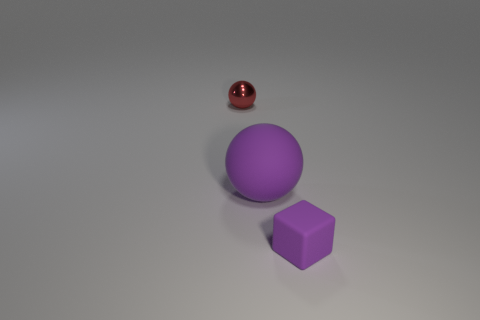What number of things are balls on the right side of the small metallic object or tiny red metallic objects?
Your answer should be compact. 2. Are there an equal number of tiny metal balls that are on the right side of the purple sphere and metal spheres in front of the small red ball?
Offer a very short reply. Yes. What number of other things are there of the same shape as the large purple thing?
Make the answer very short. 1. Does the purple object on the left side of the small purple block have the same size as the purple matte thing right of the purple sphere?
Give a very brief answer. No. What number of cylinders are small things or large purple matte things?
Your answer should be very brief. 0. What number of matte things are small things or tiny purple cubes?
Provide a short and direct response. 1. There is a purple rubber thing that is the same shape as the small red shiny thing; what size is it?
Your answer should be compact. Large. Are there any other things that are the same size as the purple rubber ball?
Offer a terse response. No. There is a metal thing; is its size the same as the ball on the right side of the red sphere?
Provide a short and direct response. No. What is the shape of the matte object that is left of the small rubber thing?
Your response must be concise. Sphere. 